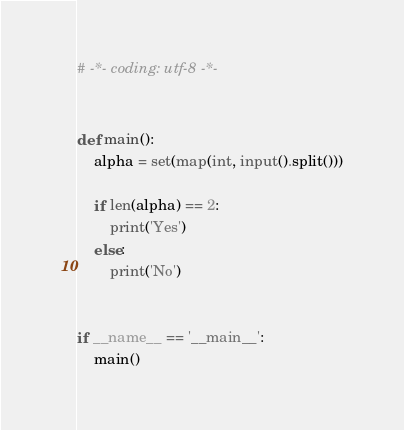Convert code to text. <code><loc_0><loc_0><loc_500><loc_500><_Python_># -*- coding: utf-8 -*-


def main():
    alpha = set(map(int, input().split()))

    if len(alpha) == 2:
        print('Yes')
    else:
        print('No')


if __name__ == '__main__':
    main()
</code> 